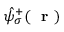<formula> <loc_0><loc_0><loc_500><loc_500>\hat { \psi } _ { \sigma } ^ { + } ( r )</formula> 